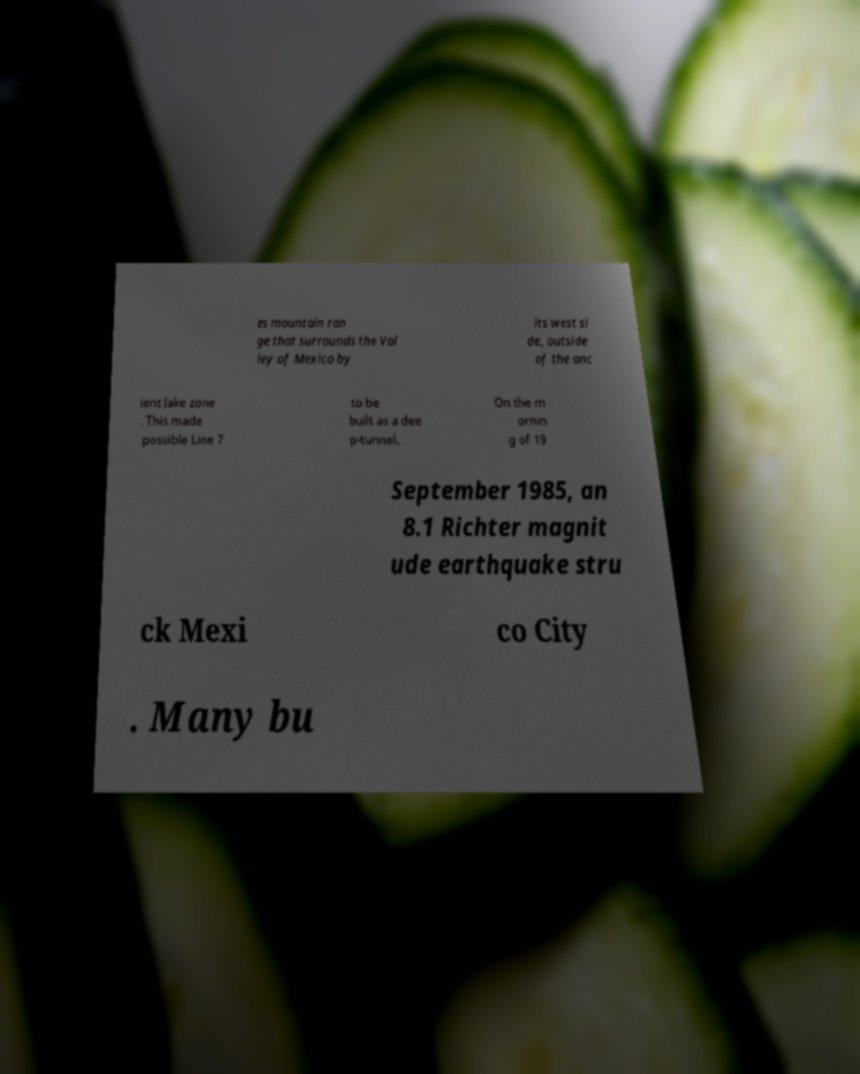For documentation purposes, I need the text within this image transcribed. Could you provide that? es mountain ran ge that surrounds the Val ley of Mexico by its west si de, outside of the anc ient lake zone . This made possible Line 7 to be built as a dee p-tunnel. On the m ornin g of 19 September 1985, an 8.1 Richter magnit ude earthquake stru ck Mexi co City . Many bu 